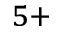Convert formula to latex. <formula><loc_0><loc_0><loc_500><loc_500>^ { 5 + }</formula> 